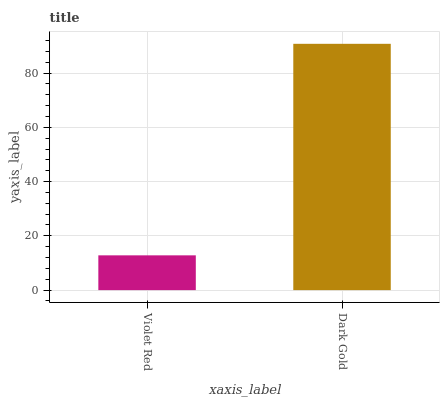Is Violet Red the minimum?
Answer yes or no. Yes. Is Dark Gold the maximum?
Answer yes or no. Yes. Is Dark Gold the minimum?
Answer yes or no. No. Is Dark Gold greater than Violet Red?
Answer yes or no. Yes. Is Violet Red less than Dark Gold?
Answer yes or no. Yes. Is Violet Red greater than Dark Gold?
Answer yes or no. No. Is Dark Gold less than Violet Red?
Answer yes or no. No. Is Dark Gold the high median?
Answer yes or no. Yes. Is Violet Red the low median?
Answer yes or no. Yes. Is Violet Red the high median?
Answer yes or no. No. Is Dark Gold the low median?
Answer yes or no. No. 